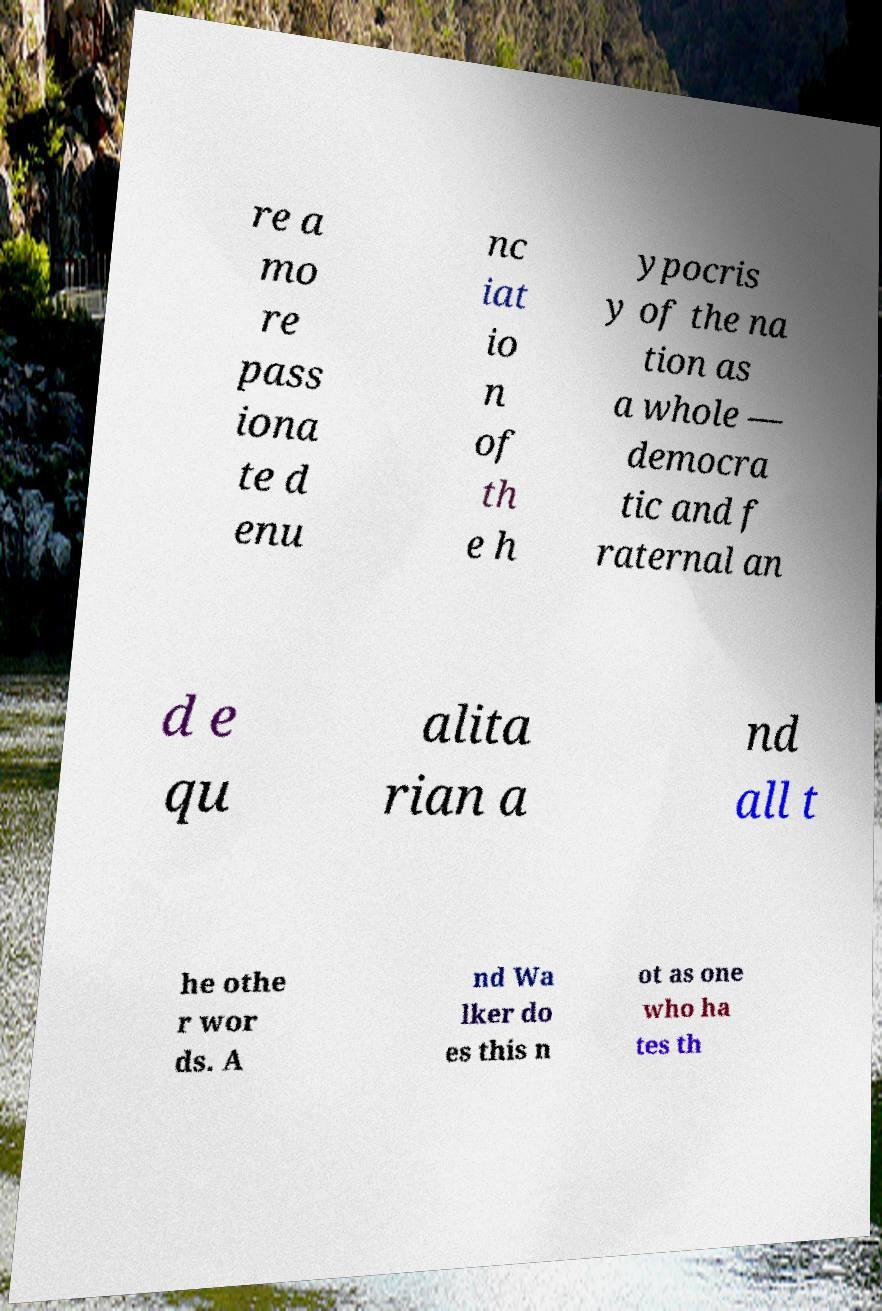Could you assist in decoding the text presented in this image and type it out clearly? re a mo re pass iona te d enu nc iat io n of th e h ypocris y of the na tion as a whole — democra tic and f raternal an d e qu alita rian a nd all t he othe r wor ds. A nd Wa lker do es this n ot as one who ha tes th 